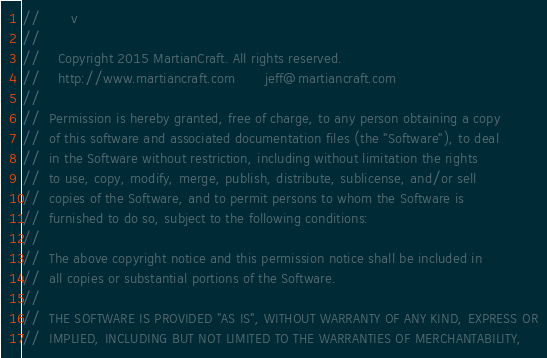Convert code to text. <code><loc_0><loc_0><loc_500><loc_500><_C_>//       v
//
//    Copyright 2015 MartianCraft. All rights reserved.
//    http://www.martiancraft.com       jeff@martiancraft.com
//
//	Permission is hereby granted, free of charge, to any person obtaining a copy
//	of this software and associated documentation files (the "Software"), to deal
//	in the Software without restriction, including without limitation the rights
//	to use, copy, modify, merge, publish, distribute, sublicense, and/or sell
//	copies of the Software, and to permit persons to whom the Software is
//	furnished to do so, subject to the following conditions:
//
//	The above copyright notice and this permission notice shall be included in
//	all copies or substantial portions of the Software.
//
//	THE SOFTWARE IS PROVIDED "AS IS", WITHOUT WARRANTY OF ANY KIND, EXPRESS OR
//	IMPLIED, INCLUDING BUT NOT LIMITED TO THE WARRANTIES OF MERCHANTABILITY,</code> 